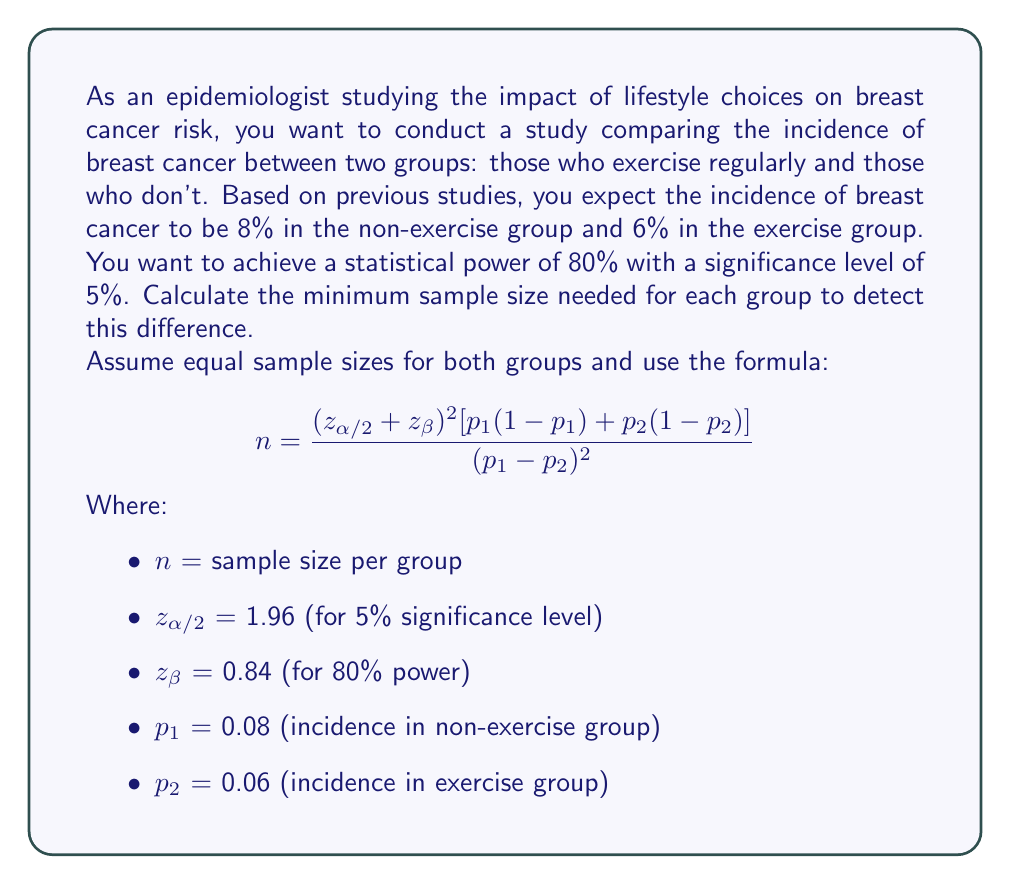Can you answer this question? To solve this problem, we'll use the given formula and substitute the known values:

$$ n = \frac{(z_{\alpha/2} + z_{\beta})^2 [p_1(1-p_1) + p_2(1-p_2)]}{(p_1 - p_2)^2} $$

1) First, let's substitute the known values:
   $z_{\alpha/2}$ = 1.96
   $z_{\beta}$ = 0.84
   $p_1$ = 0.08
   $p_2$ = 0.06

2) Calculate the numerator:
   $(1.96 + 0.84)^2 = 2.8^2 = 7.84$
   $0.08(1-0.08) + 0.06(1-0.06) = 0.0736 + 0.0564 = 0.13$
   $7.84 \times 0.13 = 1.0192$

3) Calculate the denominator:
   $(0.08 - 0.06)^2 = 0.02^2 = 0.0004$

4) Divide the numerator by the denominator:
   $n = \frac{1.0192}{0.0004} = 2548$

5) Round up to the nearest whole number:
   $n \approx 2548$

Therefore, we need at least 2,548 participants in each group for the study to have sufficient statistical power to detect the expected difference in breast cancer incidence between the exercise and non-exercise groups.
Answer: 2,548 participants per group 